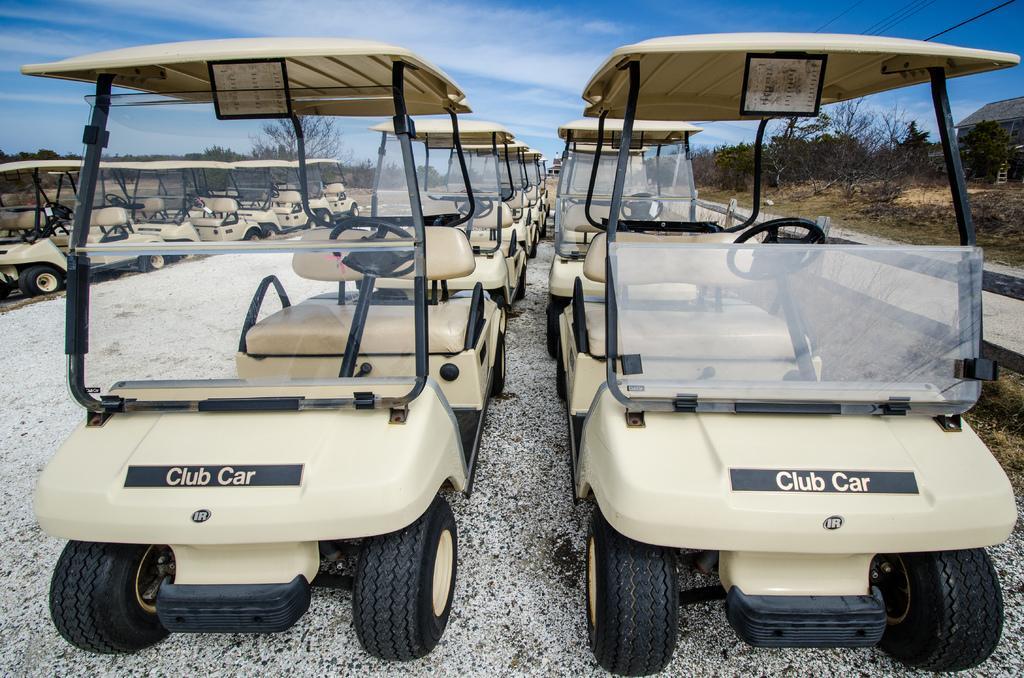In one or two sentences, can you explain what this image depicts? In this image I can see few vehicles, they are in black and brown color. Background I can see trees in green color and the sky is in blue and white color. 